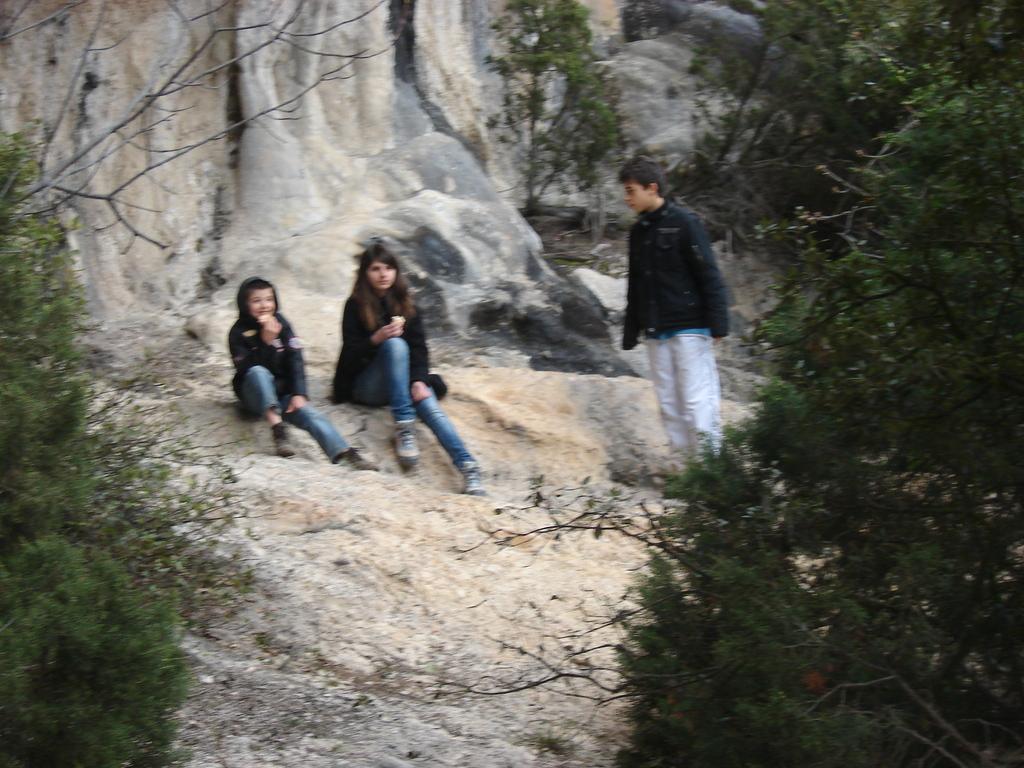In one or two sentences, can you explain what this image depicts? In this image there are some people sitting in rock behind them there is a rock mountain and some trees around them. 